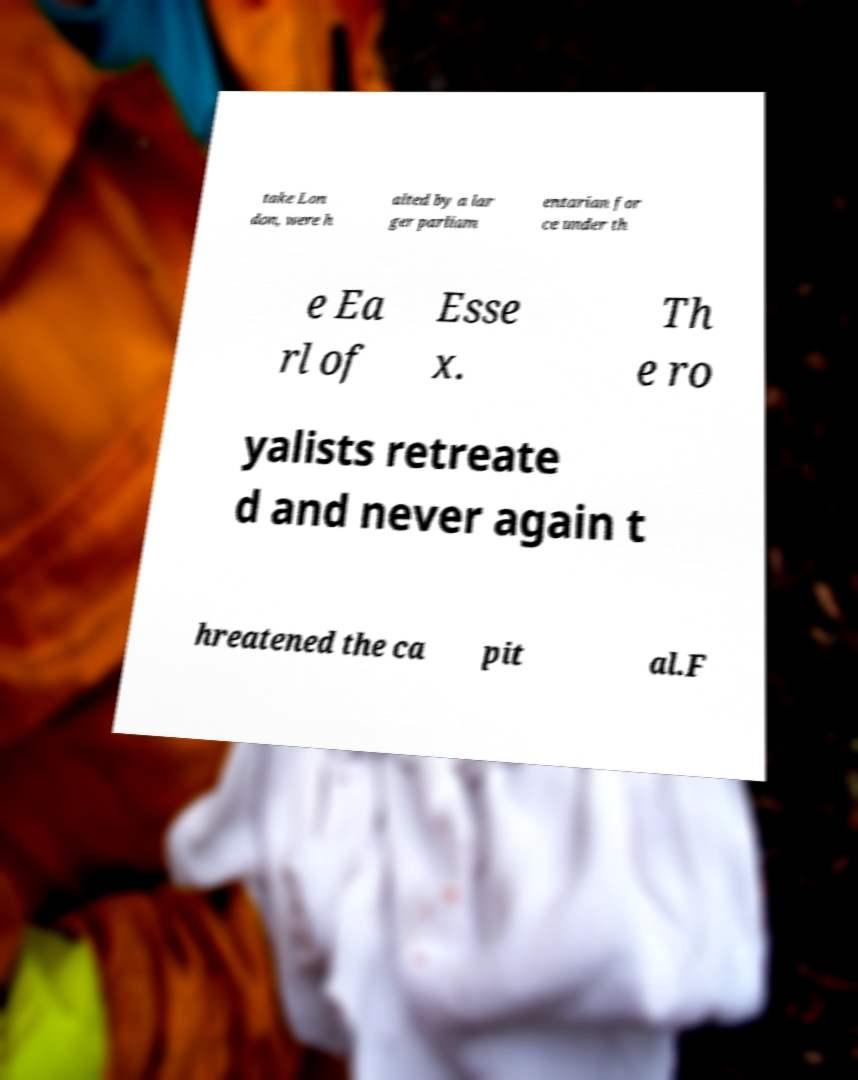Can you accurately transcribe the text from the provided image for me? take Lon don, were h alted by a lar ger parliam entarian for ce under th e Ea rl of Esse x. Th e ro yalists retreate d and never again t hreatened the ca pit al.F 